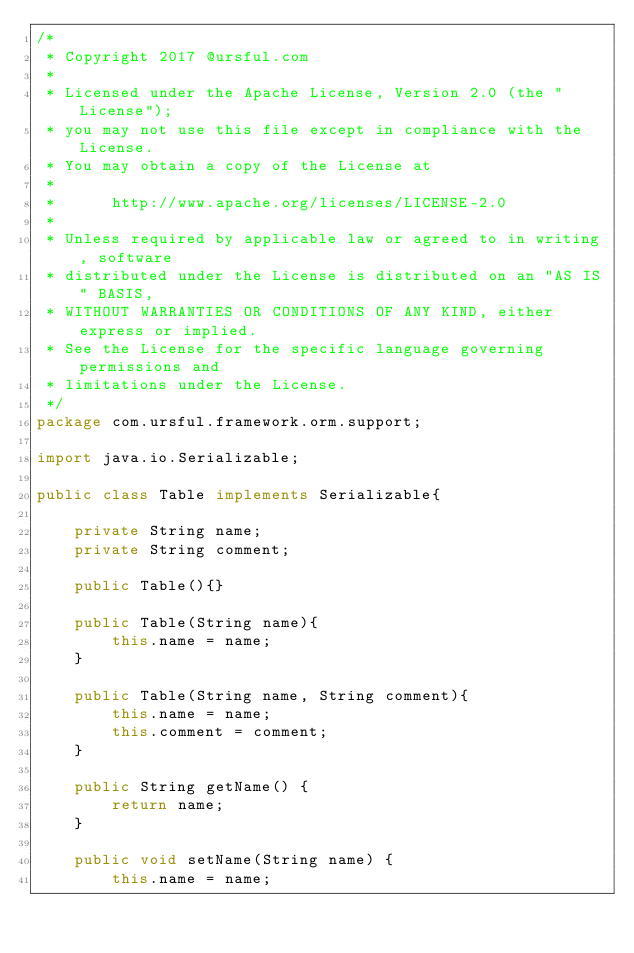Convert code to text. <code><loc_0><loc_0><loc_500><loc_500><_Java_>/*
 * Copyright 2017 @ursful.com
 *
 * Licensed under the Apache License, Version 2.0 (the "License");
 * you may not use this file except in compliance with the License.
 * You may obtain a copy of the License at
 *
 *      http://www.apache.org/licenses/LICENSE-2.0
 *
 * Unless required by applicable law or agreed to in writing, software
 * distributed under the License is distributed on an "AS IS" BASIS,
 * WITHOUT WARRANTIES OR CONDITIONS OF ANY KIND, either express or implied.
 * See the License for the specific language governing permissions and
 * limitations under the License.
 */
package com.ursful.framework.orm.support;

import java.io.Serializable;

public class Table implements Serializable{

    private String name;
    private String comment;

    public Table(){}

    public Table(String name){
        this.name = name;
    }

    public Table(String name, String comment){
        this.name = name;
        this.comment = comment;
    }

    public String getName() {
        return name;
    }

    public void setName(String name) {
        this.name = name;</code> 